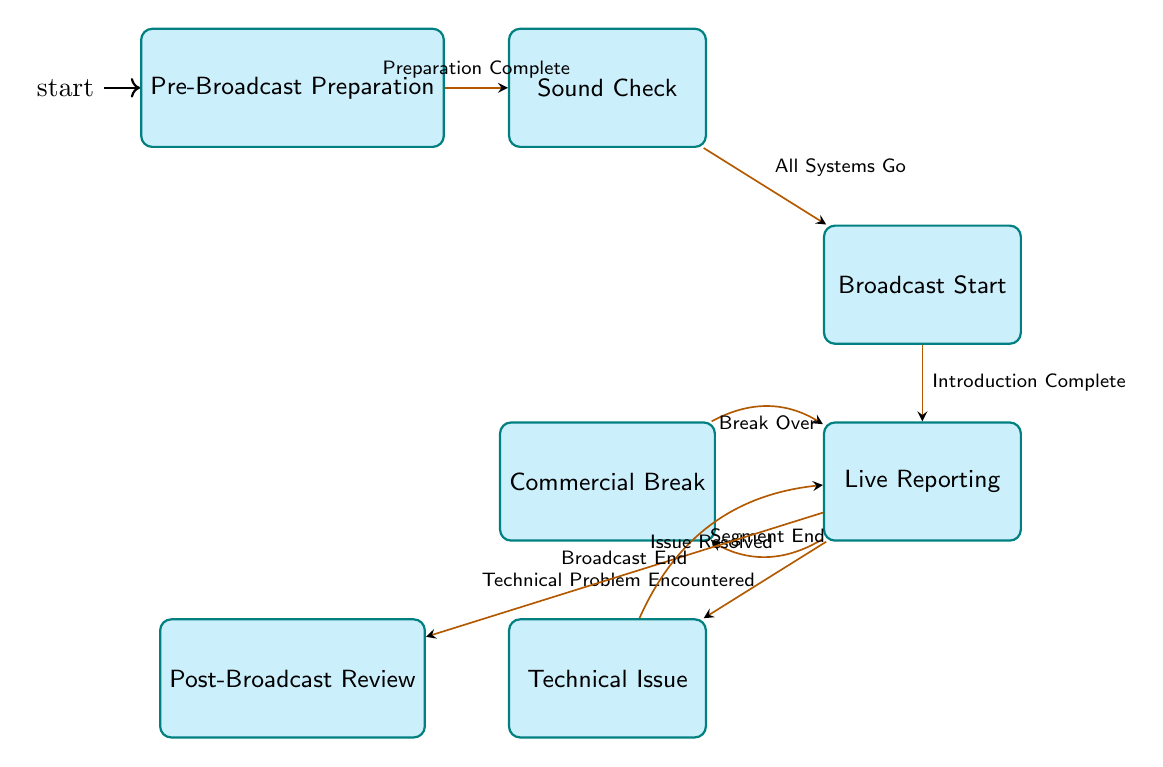What is the starting state of the broadcast day schedule management? The starting state is indicated as the initial state in the diagram, which is "Pre-Broadcast Preparation."
Answer: Pre-Broadcast Preparation How many states are present in the diagram? By counting the individual states listed in the `states` section of the data, there are seven states specified in the diagram.
Answer: 7 What transition occurs after "Sound Check"? The transition from "Sound Check" occurs when the trigger "All Systems Go" is activated, which connects it to the next state "Broadcast Start."
Answer: Broadcast Start What happens when a technical problem is encountered during "Live Reporting"? When a "Technical Problem Encountered" is detected in "Live Reporting," the state transitions to "Technical Issue," indicating an unexpected problem.
Answer: Technical Issue What state follows "Commercial Break"? After the "Commercial Break," the flow returns to "Live Reporting" when the trigger "Break Over" is activated.
Answer: Live Reporting What is the final state after all reporting is completed? The final state reached after concluding the broadcast is "Post-Broadcast Review," which takes place after the trigger "Broadcast End."
Answer: Post-Broadcast Review Which state can transition to "Technical Issue"? The state "Live Reporting" can transition to "Technical Issue" when a "Technical Problem Encountered" occurs, indicating there's a need to address technical difficulties.
Answer: Live Reporting What trigger is required to move from "Pre-Broadcast Preparation" to "Sound Check"? The transition from "Pre-Broadcast Preparation" to "Sound Check" is triggered by the completion of the preparations, specified as "Preparation Complete."
Answer: Preparation Complete What occurs when an issue is resolved in "Technical Issue"? When the situation in "Technical Issue" is resolved, the flow transitions back to "Live Reporting," indicating that broadcasting can continue.
Answer: Live Reporting 